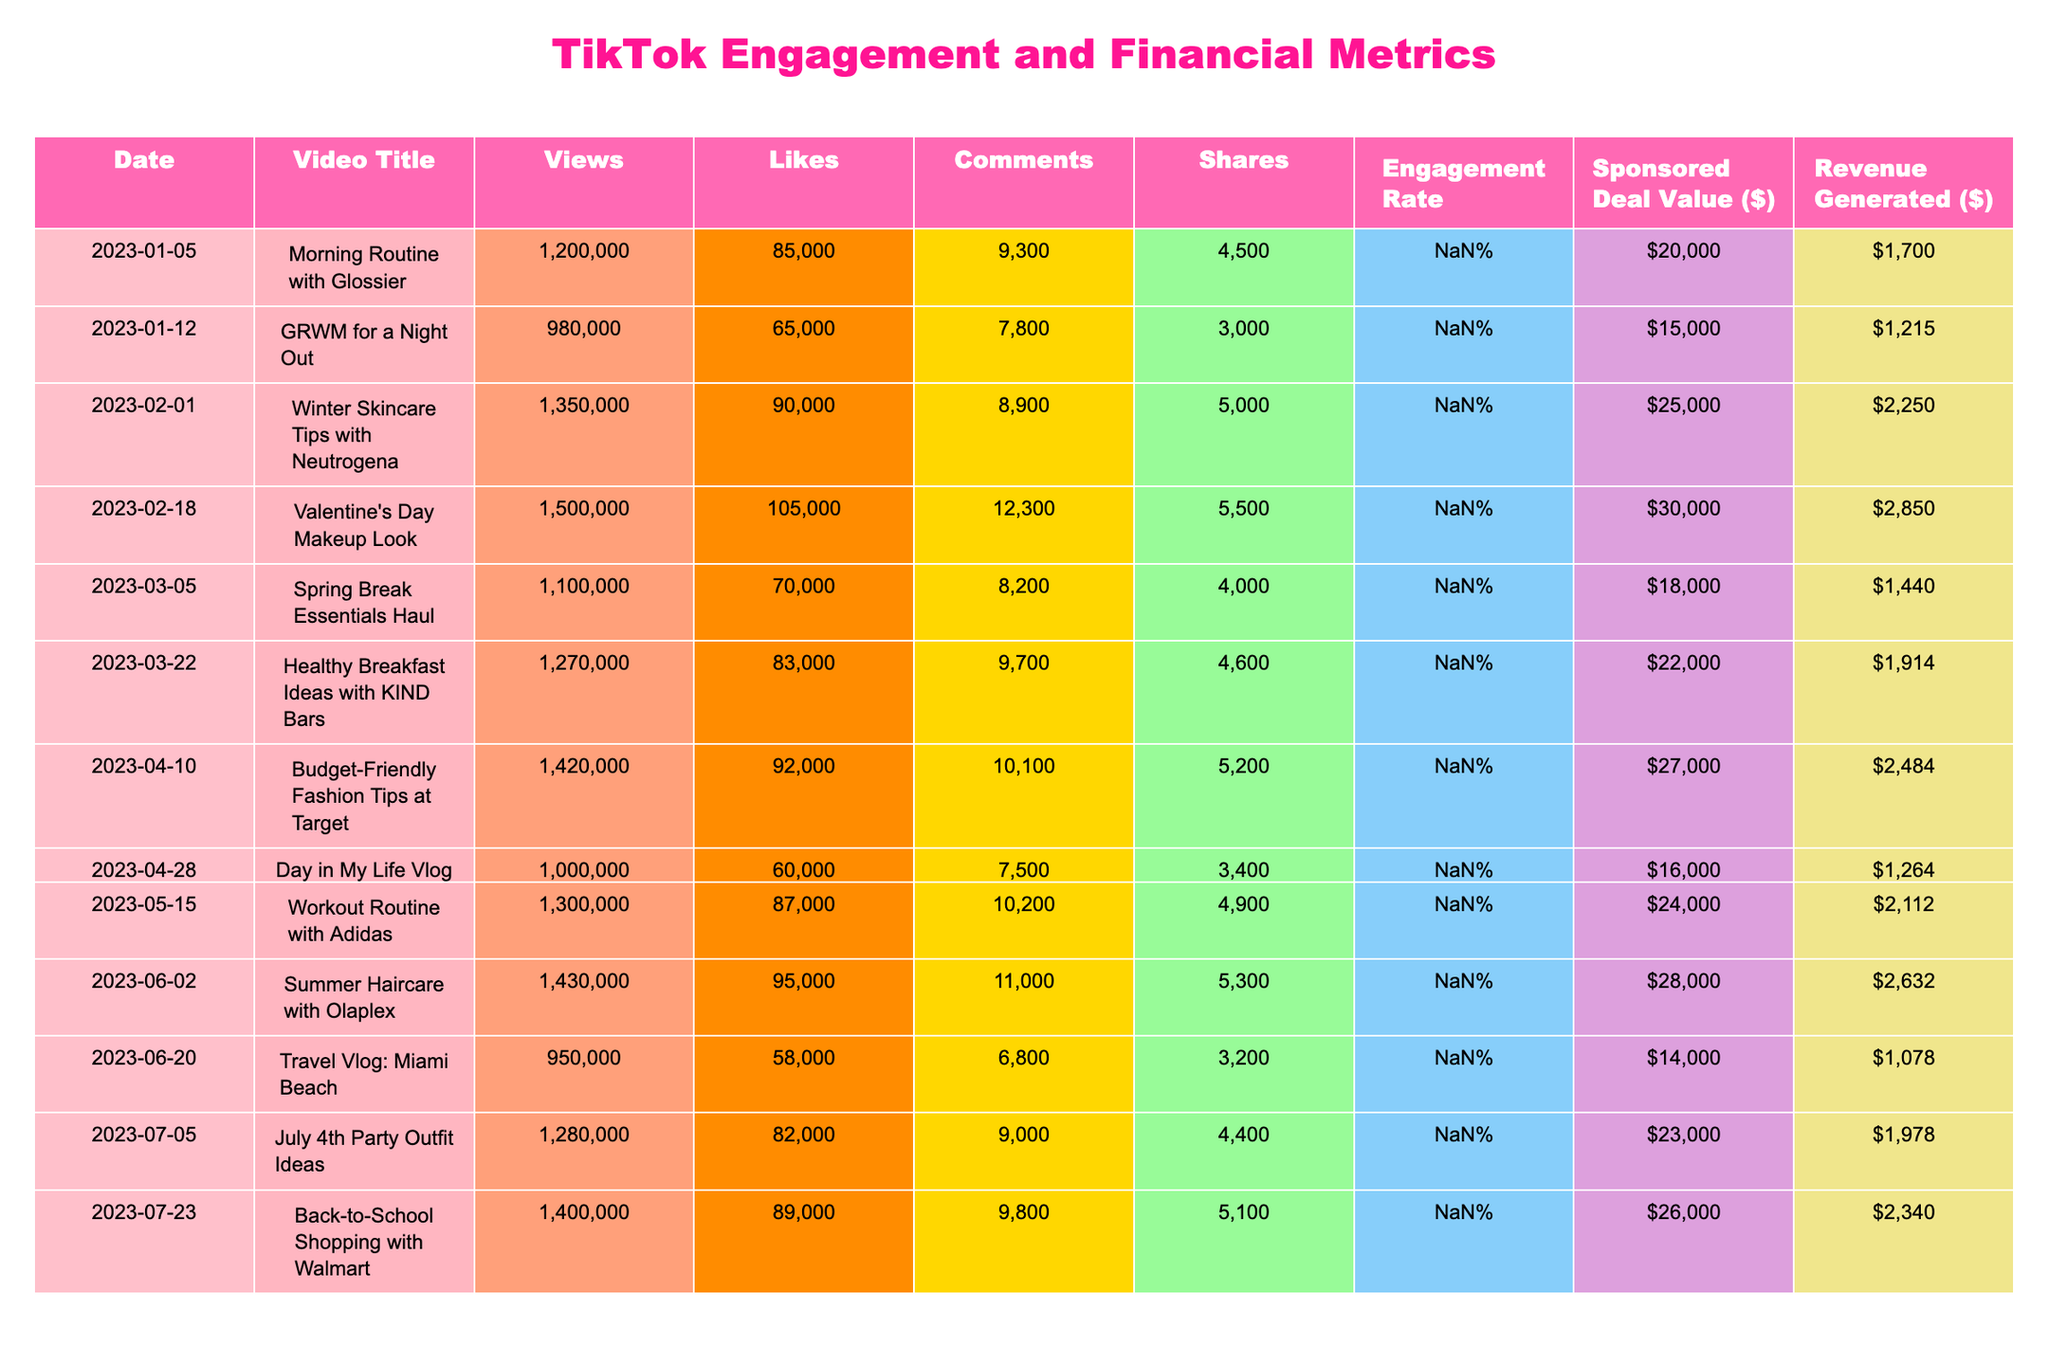What's the video title with the highest engagement rate? The engagement rate is highest for "Valentine's Day Makeup Look" at 9.5%. This can be determined by scanning through the engagement rate column and identifying the maximum value.
Answer: Valentine's Day Makeup Look How many shares did the video titled "Summer Haircare with Olaplex" receive? The video "Summer Haircare with Olaplex" received 5,300 shares, which is directly found in the shares column corresponding to that video title.
Answer: 5300 What is the total revenue generated from all videos? To find the total revenue generated, we sum all the revenue generated values: (1700 + 1215 + 2250 + 2850 + 1440 + 1914 + 2484 + 1264 + 2112 + 2632 + 1078 + 1978 + 2340) = 22883.
Answer: 22883 What is the average sponsored deal value for videos with an engagement rate greater than 9%? First, we identify the videos with an engagement rate above 9%, which are "Winter Skincare Tips with Neutrogena", "Valentine's Day Makeup Look", "Budget-Friendly Fashion Tips at Target", "Summer Haircare with Olaplex", and "Back-to-School Shopping with Walmart". Their deal values are 25000, 30000, 27000, 28000, and 26000. The average is calculated as (25000 + 30000 + 27000 + 28000 + 26000) / 5 = 27200.
Answer: 27200 Did the video "Workout Routine with Adidas" generate more revenue than the "Day in My Life Vlog"? Yes, "Workout Routine with Adidas" generated $2,112 while "Day in My Life Vlog" generated $1,264. By comparing these two revenue figures, it is confirmed that the former is greater.
Answer: Yes What is the difference in views between the highest and lowest performing video? The highest performing video is "Valentine's Day Makeup Look" with 1,500,000 views, and the lowest is "Travel Vlog: Miami Beach" with 950,000 views. The difference is 1,500,000 - 950,000 = 550,000 views.
Answer: 550000 Which video had the most comments and how many did it receive? The video with the most comments is "Valentine's Day Makeup Look," with 12,300 comments, which can be seen in the comments column.
Answer: 12300 How many videos had a sponsored deal value of over $25,000? There are five videos with a sponsored deal value greater than $25,000: "Winter Skincare Tips with Neutrogena" (25,000), "Valentine's Day Makeup Look" (30,000), "Budget-Friendly Fashion Tips at Target" (27,000), "Summer Haircare with Olaplex" (28,000), and "Back-to-School Shopping with Walmart" (26,000). Counting these gives a total of five videos.
Answer: 5 